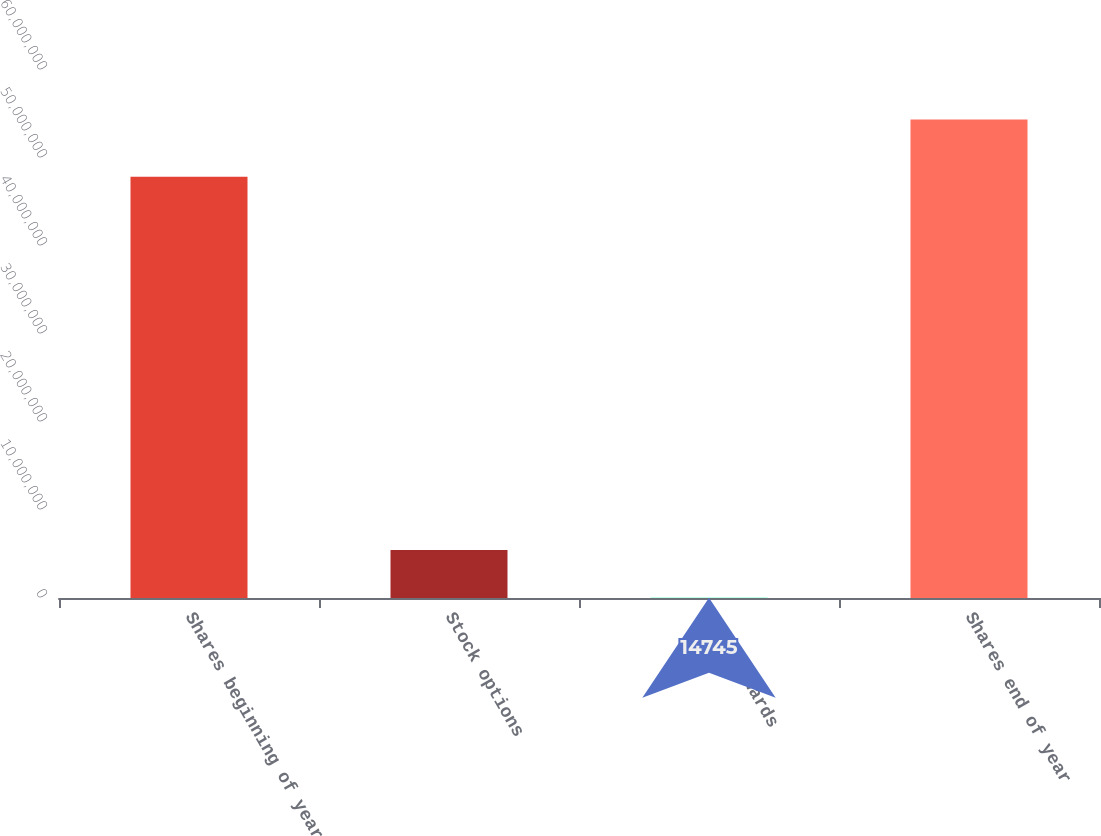<chart> <loc_0><loc_0><loc_500><loc_500><bar_chart><fcel>Shares beginning of year<fcel>Stock options<fcel>Stock awards<fcel>Shares end of year<nl><fcel>4.78723e+07<fcel>5.45054e+06<fcel>14745<fcel>5.43727e+07<nl></chart> 